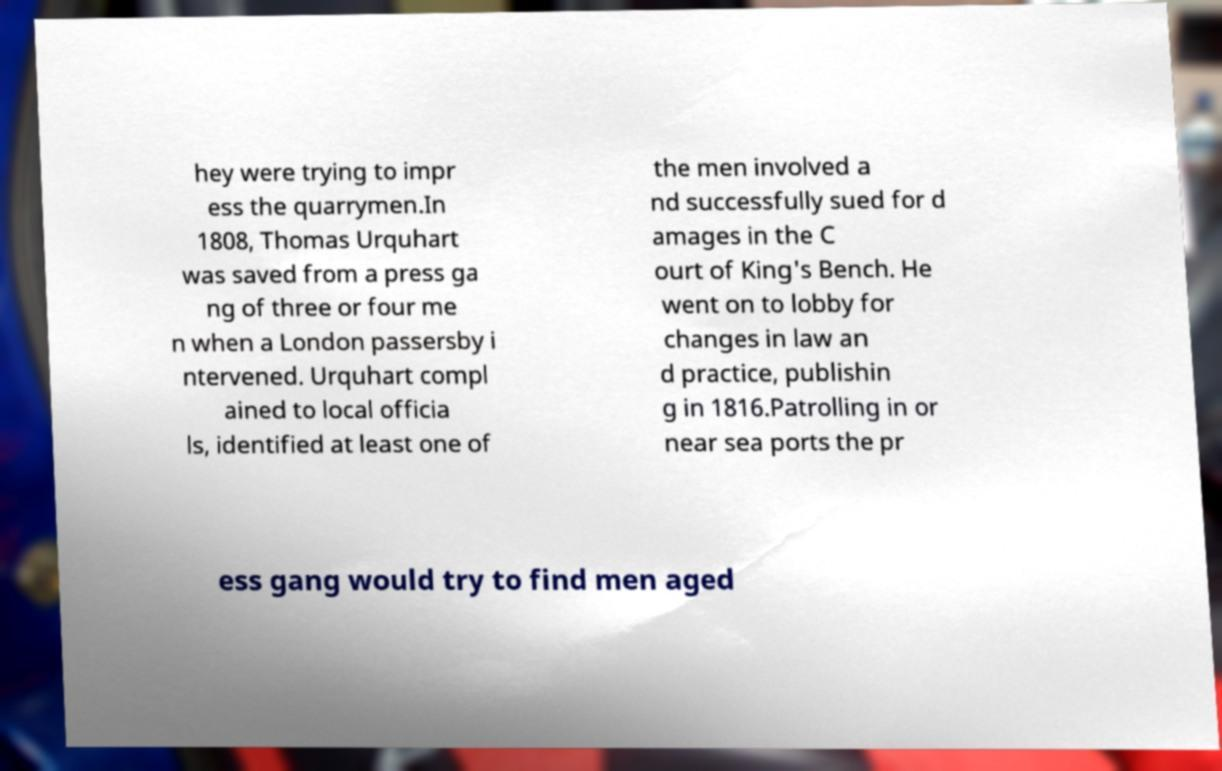Please identify and transcribe the text found in this image. hey were trying to impr ess the quarrymen.In 1808, Thomas Urquhart was saved from a press ga ng of three or four me n when a London passersby i ntervened. Urquhart compl ained to local officia ls, identified at least one of the men involved a nd successfully sued for d amages in the C ourt of King's Bench. He went on to lobby for changes in law an d practice, publishin g in 1816.Patrolling in or near sea ports the pr ess gang would try to find men aged 